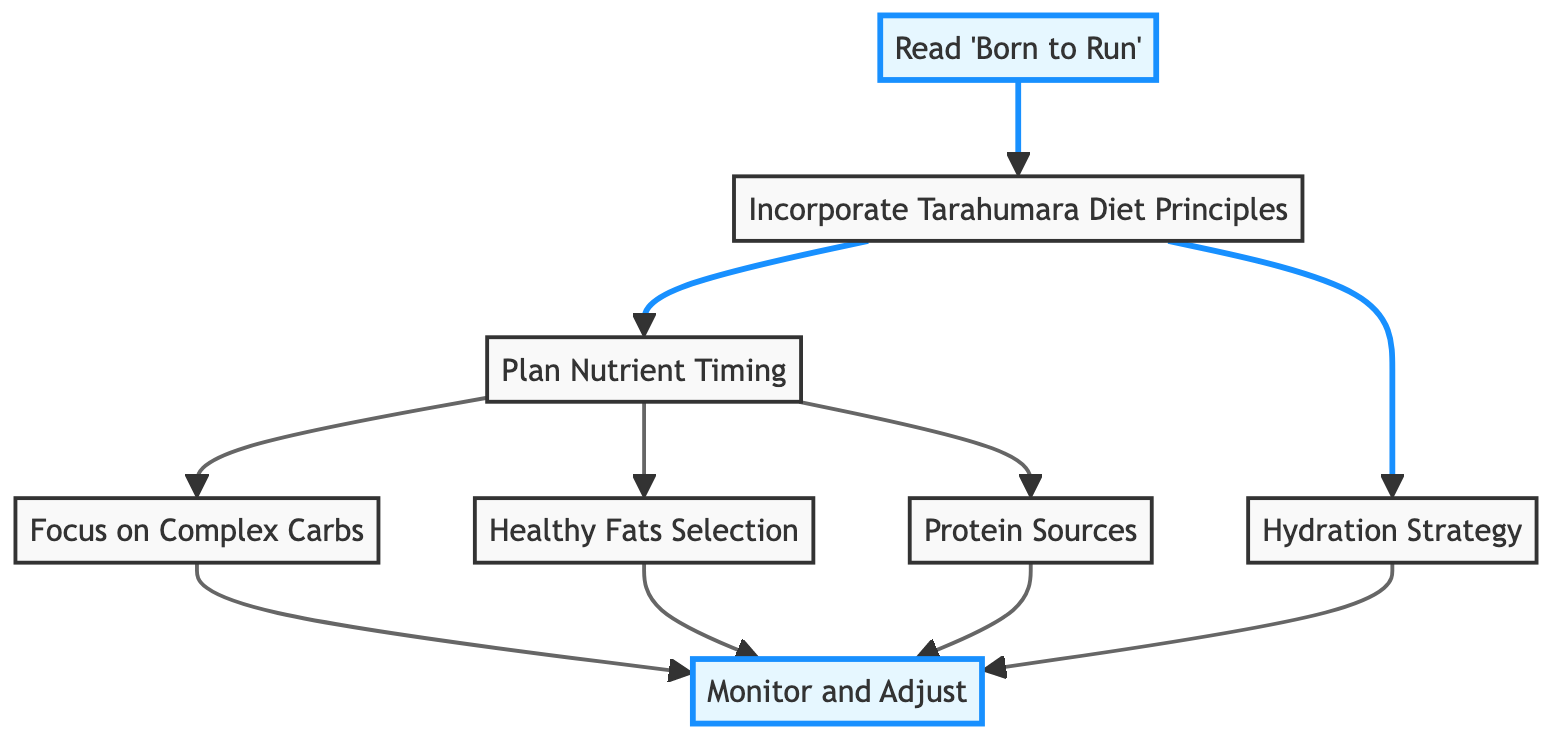What is the first step in the nutrition plan? The first step in the flow chart is "Read 'Born to Run'", which is represented as node 1. This step does not have any dependencies, meaning it is the initial action to take.
Answer: Read 'Born to Run' How many steps are there in the nutrition plan? By counting each node listed in the flow chart, there are a total of 8 steps included in the nutrition plan.
Answer: 8 What is the last step in the nutrition plan? The last step, which is the concluding action of the flow chart, is "Monitor and Adjust," labeled as node 8.
Answer: Monitor and Adjust What steps depend on "Plan Nutrient Timing"? "Focus on Complex Carbs," "Healthy Fats Selection," and "Protein Sources" are the steps that require "Plan Nutrient Timing" to be completed first, as indicated by the arrows in the flow.
Answer: Focus on Complex Carbs, Healthy Fats Selection, Protein Sources Which steps come after "Incorporate Tarahumara Diet Principles"? The steps that follow "Incorporate Tarahumara Diet Principles" are "Plan Nutrient Timing" and "Hydration Strategy", as they both depend on the completion of the second step.
Answer: Plan Nutrient Timing, Hydration Strategy What are the dependent steps for "Monitor and Adjust"? "Monitor and Adjust" depends on four different steps: "Focus on Complex Carbs," "Healthy Fats Selection," "Protein Sources," and "Hydration Strategy," which are all required to be accomplished before this final step.
Answer: Focus on Complex Carbs, Healthy Fats Selection, Protein Sources, Hydration Strategy Which step focuses specifically on carbs? The step that focuses specifically on carbs is "Focus on Complex Carbs," as indicated clearly within the flow chart under that label.
Answer: Focus on Complex Carbs What is one key aspect of the "Hydration Strategy" step? The "Hydration Strategy" step emphasizes the need for adequate hydration with water and electrolytes, which is crucial for performance before, during, and after training.
Answer: Adequate hydration with water and electrolytes 